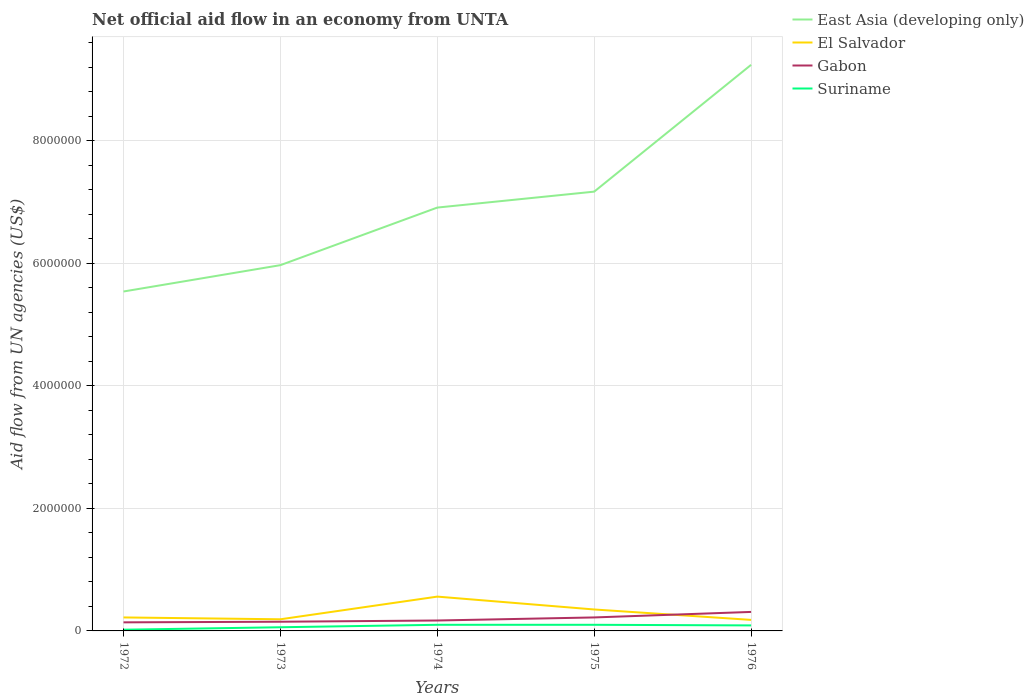In which year was the net official aid flow in El Salvador maximum?
Ensure brevity in your answer.  1976. What is the total net official aid flow in Gabon in the graph?
Offer a very short reply. -5.00e+04. How many lines are there?
Provide a short and direct response. 4. How many years are there in the graph?
Your answer should be very brief. 5. Are the values on the major ticks of Y-axis written in scientific E-notation?
Your answer should be compact. No. Does the graph contain any zero values?
Give a very brief answer. No. What is the title of the graph?
Keep it short and to the point. Net official aid flow in an economy from UNTA. Does "Greenland" appear as one of the legend labels in the graph?
Make the answer very short. No. What is the label or title of the Y-axis?
Make the answer very short. Aid flow from UN agencies (US$). What is the Aid flow from UN agencies (US$) of East Asia (developing only) in 1972?
Your answer should be very brief. 5.54e+06. What is the Aid flow from UN agencies (US$) in El Salvador in 1972?
Your response must be concise. 2.20e+05. What is the Aid flow from UN agencies (US$) of East Asia (developing only) in 1973?
Make the answer very short. 5.97e+06. What is the Aid flow from UN agencies (US$) in Gabon in 1973?
Your answer should be very brief. 1.50e+05. What is the Aid flow from UN agencies (US$) of Suriname in 1973?
Keep it short and to the point. 6.00e+04. What is the Aid flow from UN agencies (US$) in East Asia (developing only) in 1974?
Offer a very short reply. 6.91e+06. What is the Aid flow from UN agencies (US$) of El Salvador in 1974?
Give a very brief answer. 5.60e+05. What is the Aid flow from UN agencies (US$) of Gabon in 1974?
Keep it short and to the point. 1.70e+05. What is the Aid flow from UN agencies (US$) of East Asia (developing only) in 1975?
Ensure brevity in your answer.  7.17e+06. What is the Aid flow from UN agencies (US$) in Gabon in 1975?
Your response must be concise. 2.20e+05. What is the Aid flow from UN agencies (US$) in East Asia (developing only) in 1976?
Your answer should be very brief. 9.24e+06. What is the Aid flow from UN agencies (US$) of El Salvador in 1976?
Make the answer very short. 1.80e+05. What is the Aid flow from UN agencies (US$) in Gabon in 1976?
Offer a terse response. 3.10e+05. What is the Aid flow from UN agencies (US$) in Suriname in 1976?
Give a very brief answer. 9.00e+04. Across all years, what is the maximum Aid flow from UN agencies (US$) in East Asia (developing only)?
Offer a very short reply. 9.24e+06. Across all years, what is the maximum Aid flow from UN agencies (US$) in El Salvador?
Make the answer very short. 5.60e+05. Across all years, what is the minimum Aid flow from UN agencies (US$) of East Asia (developing only)?
Your answer should be compact. 5.54e+06. Across all years, what is the minimum Aid flow from UN agencies (US$) in Suriname?
Provide a succinct answer. 2.00e+04. What is the total Aid flow from UN agencies (US$) in East Asia (developing only) in the graph?
Make the answer very short. 3.48e+07. What is the total Aid flow from UN agencies (US$) in El Salvador in the graph?
Your answer should be compact. 1.50e+06. What is the total Aid flow from UN agencies (US$) in Gabon in the graph?
Ensure brevity in your answer.  9.90e+05. What is the difference between the Aid flow from UN agencies (US$) of East Asia (developing only) in 1972 and that in 1973?
Provide a short and direct response. -4.30e+05. What is the difference between the Aid flow from UN agencies (US$) in East Asia (developing only) in 1972 and that in 1974?
Provide a succinct answer. -1.37e+06. What is the difference between the Aid flow from UN agencies (US$) of Gabon in 1972 and that in 1974?
Your answer should be compact. -3.00e+04. What is the difference between the Aid flow from UN agencies (US$) in East Asia (developing only) in 1972 and that in 1975?
Ensure brevity in your answer.  -1.63e+06. What is the difference between the Aid flow from UN agencies (US$) in El Salvador in 1972 and that in 1975?
Provide a short and direct response. -1.30e+05. What is the difference between the Aid flow from UN agencies (US$) of Suriname in 1972 and that in 1975?
Your answer should be compact. -8.00e+04. What is the difference between the Aid flow from UN agencies (US$) of East Asia (developing only) in 1972 and that in 1976?
Offer a terse response. -3.70e+06. What is the difference between the Aid flow from UN agencies (US$) of Suriname in 1972 and that in 1976?
Keep it short and to the point. -7.00e+04. What is the difference between the Aid flow from UN agencies (US$) in East Asia (developing only) in 1973 and that in 1974?
Provide a succinct answer. -9.40e+05. What is the difference between the Aid flow from UN agencies (US$) in El Salvador in 1973 and that in 1974?
Provide a short and direct response. -3.70e+05. What is the difference between the Aid flow from UN agencies (US$) in Gabon in 1973 and that in 1974?
Make the answer very short. -2.00e+04. What is the difference between the Aid flow from UN agencies (US$) in Suriname in 1973 and that in 1974?
Give a very brief answer. -4.00e+04. What is the difference between the Aid flow from UN agencies (US$) in East Asia (developing only) in 1973 and that in 1975?
Provide a succinct answer. -1.20e+06. What is the difference between the Aid flow from UN agencies (US$) of Gabon in 1973 and that in 1975?
Offer a terse response. -7.00e+04. What is the difference between the Aid flow from UN agencies (US$) in East Asia (developing only) in 1973 and that in 1976?
Ensure brevity in your answer.  -3.27e+06. What is the difference between the Aid flow from UN agencies (US$) in El Salvador in 1973 and that in 1976?
Provide a succinct answer. 10000. What is the difference between the Aid flow from UN agencies (US$) of Suriname in 1973 and that in 1976?
Offer a terse response. -3.00e+04. What is the difference between the Aid flow from UN agencies (US$) of East Asia (developing only) in 1974 and that in 1975?
Provide a short and direct response. -2.60e+05. What is the difference between the Aid flow from UN agencies (US$) of Gabon in 1974 and that in 1975?
Keep it short and to the point. -5.00e+04. What is the difference between the Aid flow from UN agencies (US$) of Suriname in 1974 and that in 1975?
Keep it short and to the point. 0. What is the difference between the Aid flow from UN agencies (US$) in East Asia (developing only) in 1974 and that in 1976?
Offer a very short reply. -2.33e+06. What is the difference between the Aid flow from UN agencies (US$) in El Salvador in 1974 and that in 1976?
Give a very brief answer. 3.80e+05. What is the difference between the Aid flow from UN agencies (US$) in Gabon in 1974 and that in 1976?
Make the answer very short. -1.40e+05. What is the difference between the Aid flow from UN agencies (US$) of Suriname in 1974 and that in 1976?
Your response must be concise. 10000. What is the difference between the Aid flow from UN agencies (US$) in East Asia (developing only) in 1975 and that in 1976?
Your answer should be very brief. -2.07e+06. What is the difference between the Aid flow from UN agencies (US$) of Gabon in 1975 and that in 1976?
Provide a succinct answer. -9.00e+04. What is the difference between the Aid flow from UN agencies (US$) of East Asia (developing only) in 1972 and the Aid flow from UN agencies (US$) of El Salvador in 1973?
Your answer should be compact. 5.35e+06. What is the difference between the Aid flow from UN agencies (US$) in East Asia (developing only) in 1972 and the Aid flow from UN agencies (US$) in Gabon in 1973?
Your response must be concise. 5.39e+06. What is the difference between the Aid flow from UN agencies (US$) of East Asia (developing only) in 1972 and the Aid flow from UN agencies (US$) of Suriname in 1973?
Provide a succinct answer. 5.48e+06. What is the difference between the Aid flow from UN agencies (US$) in East Asia (developing only) in 1972 and the Aid flow from UN agencies (US$) in El Salvador in 1974?
Provide a short and direct response. 4.98e+06. What is the difference between the Aid flow from UN agencies (US$) of East Asia (developing only) in 1972 and the Aid flow from UN agencies (US$) of Gabon in 1974?
Keep it short and to the point. 5.37e+06. What is the difference between the Aid flow from UN agencies (US$) in East Asia (developing only) in 1972 and the Aid flow from UN agencies (US$) in Suriname in 1974?
Provide a short and direct response. 5.44e+06. What is the difference between the Aid flow from UN agencies (US$) of El Salvador in 1972 and the Aid flow from UN agencies (US$) of Gabon in 1974?
Your response must be concise. 5.00e+04. What is the difference between the Aid flow from UN agencies (US$) in El Salvador in 1972 and the Aid flow from UN agencies (US$) in Suriname in 1974?
Provide a short and direct response. 1.20e+05. What is the difference between the Aid flow from UN agencies (US$) of East Asia (developing only) in 1972 and the Aid flow from UN agencies (US$) of El Salvador in 1975?
Keep it short and to the point. 5.19e+06. What is the difference between the Aid flow from UN agencies (US$) of East Asia (developing only) in 1972 and the Aid flow from UN agencies (US$) of Gabon in 1975?
Give a very brief answer. 5.32e+06. What is the difference between the Aid flow from UN agencies (US$) in East Asia (developing only) in 1972 and the Aid flow from UN agencies (US$) in Suriname in 1975?
Keep it short and to the point. 5.44e+06. What is the difference between the Aid flow from UN agencies (US$) of Gabon in 1972 and the Aid flow from UN agencies (US$) of Suriname in 1975?
Your answer should be compact. 4.00e+04. What is the difference between the Aid flow from UN agencies (US$) of East Asia (developing only) in 1972 and the Aid flow from UN agencies (US$) of El Salvador in 1976?
Your answer should be very brief. 5.36e+06. What is the difference between the Aid flow from UN agencies (US$) in East Asia (developing only) in 1972 and the Aid flow from UN agencies (US$) in Gabon in 1976?
Offer a very short reply. 5.23e+06. What is the difference between the Aid flow from UN agencies (US$) in East Asia (developing only) in 1972 and the Aid flow from UN agencies (US$) in Suriname in 1976?
Your answer should be very brief. 5.45e+06. What is the difference between the Aid flow from UN agencies (US$) of El Salvador in 1972 and the Aid flow from UN agencies (US$) of Gabon in 1976?
Your answer should be very brief. -9.00e+04. What is the difference between the Aid flow from UN agencies (US$) of East Asia (developing only) in 1973 and the Aid flow from UN agencies (US$) of El Salvador in 1974?
Your response must be concise. 5.41e+06. What is the difference between the Aid flow from UN agencies (US$) of East Asia (developing only) in 1973 and the Aid flow from UN agencies (US$) of Gabon in 1974?
Offer a very short reply. 5.80e+06. What is the difference between the Aid flow from UN agencies (US$) in East Asia (developing only) in 1973 and the Aid flow from UN agencies (US$) in Suriname in 1974?
Ensure brevity in your answer.  5.87e+06. What is the difference between the Aid flow from UN agencies (US$) in El Salvador in 1973 and the Aid flow from UN agencies (US$) in Gabon in 1974?
Keep it short and to the point. 2.00e+04. What is the difference between the Aid flow from UN agencies (US$) in Gabon in 1973 and the Aid flow from UN agencies (US$) in Suriname in 1974?
Give a very brief answer. 5.00e+04. What is the difference between the Aid flow from UN agencies (US$) of East Asia (developing only) in 1973 and the Aid flow from UN agencies (US$) of El Salvador in 1975?
Offer a terse response. 5.62e+06. What is the difference between the Aid flow from UN agencies (US$) of East Asia (developing only) in 1973 and the Aid flow from UN agencies (US$) of Gabon in 1975?
Make the answer very short. 5.75e+06. What is the difference between the Aid flow from UN agencies (US$) of East Asia (developing only) in 1973 and the Aid flow from UN agencies (US$) of Suriname in 1975?
Give a very brief answer. 5.87e+06. What is the difference between the Aid flow from UN agencies (US$) of El Salvador in 1973 and the Aid flow from UN agencies (US$) of Gabon in 1975?
Offer a terse response. -3.00e+04. What is the difference between the Aid flow from UN agencies (US$) of El Salvador in 1973 and the Aid flow from UN agencies (US$) of Suriname in 1975?
Give a very brief answer. 9.00e+04. What is the difference between the Aid flow from UN agencies (US$) of East Asia (developing only) in 1973 and the Aid flow from UN agencies (US$) of El Salvador in 1976?
Your answer should be compact. 5.79e+06. What is the difference between the Aid flow from UN agencies (US$) of East Asia (developing only) in 1973 and the Aid flow from UN agencies (US$) of Gabon in 1976?
Ensure brevity in your answer.  5.66e+06. What is the difference between the Aid flow from UN agencies (US$) of East Asia (developing only) in 1973 and the Aid flow from UN agencies (US$) of Suriname in 1976?
Offer a very short reply. 5.88e+06. What is the difference between the Aid flow from UN agencies (US$) of El Salvador in 1973 and the Aid flow from UN agencies (US$) of Gabon in 1976?
Keep it short and to the point. -1.20e+05. What is the difference between the Aid flow from UN agencies (US$) in East Asia (developing only) in 1974 and the Aid flow from UN agencies (US$) in El Salvador in 1975?
Provide a succinct answer. 6.56e+06. What is the difference between the Aid flow from UN agencies (US$) of East Asia (developing only) in 1974 and the Aid flow from UN agencies (US$) of Gabon in 1975?
Keep it short and to the point. 6.69e+06. What is the difference between the Aid flow from UN agencies (US$) of East Asia (developing only) in 1974 and the Aid flow from UN agencies (US$) of Suriname in 1975?
Your response must be concise. 6.81e+06. What is the difference between the Aid flow from UN agencies (US$) in El Salvador in 1974 and the Aid flow from UN agencies (US$) in Suriname in 1975?
Provide a succinct answer. 4.60e+05. What is the difference between the Aid flow from UN agencies (US$) of Gabon in 1974 and the Aid flow from UN agencies (US$) of Suriname in 1975?
Keep it short and to the point. 7.00e+04. What is the difference between the Aid flow from UN agencies (US$) of East Asia (developing only) in 1974 and the Aid flow from UN agencies (US$) of El Salvador in 1976?
Offer a terse response. 6.73e+06. What is the difference between the Aid flow from UN agencies (US$) of East Asia (developing only) in 1974 and the Aid flow from UN agencies (US$) of Gabon in 1976?
Give a very brief answer. 6.60e+06. What is the difference between the Aid flow from UN agencies (US$) of East Asia (developing only) in 1974 and the Aid flow from UN agencies (US$) of Suriname in 1976?
Provide a succinct answer. 6.82e+06. What is the difference between the Aid flow from UN agencies (US$) in El Salvador in 1974 and the Aid flow from UN agencies (US$) in Gabon in 1976?
Your answer should be very brief. 2.50e+05. What is the difference between the Aid flow from UN agencies (US$) in East Asia (developing only) in 1975 and the Aid flow from UN agencies (US$) in El Salvador in 1976?
Offer a very short reply. 6.99e+06. What is the difference between the Aid flow from UN agencies (US$) in East Asia (developing only) in 1975 and the Aid flow from UN agencies (US$) in Gabon in 1976?
Your answer should be compact. 6.86e+06. What is the difference between the Aid flow from UN agencies (US$) of East Asia (developing only) in 1975 and the Aid flow from UN agencies (US$) of Suriname in 1976?
Keep it short and to the point. 7.08e+06. What is the difference between the Aid flow from UN agencies (US$) of El Salvador in 1975 and the Aid flow from UN agencies (US$) of Gabon in 1976?
Offer a terse response. 4.00e+04. What is the difference between the Aid flow from UN agencies (US$) in El Salvador in 1975 and the Aid flow from UN agencies (US$) in Suriname in 1976?
Make the answer very short. 2.60e+05. What is the difference between the Aid flow from UN agencies (US$) of Gabon in 1975 and the Aid flow from UN agencies (US$) of Suriname in 1976?
Provide a short and direct response. 1.30e+05. What is the average Aid flow from UN agencies (US$) of East Asia (developing only) per year?
Provide a succinct answer. 6.97e+06. What is the average Aid flow from UN agencies (US$) in Gabon per year?
Keep it short and to the point. 1.98e+05. What is the average Aid flow from UN agencies (US$) of Suriname per year?
Your answer should be compact. 7.40e+04. In the year 1972, what is the difference between the Aid flow from UN agencies (US$) of East Asia (developing only) and Aid flow from UN agencies (US$) of El Salvador?
Your response must be concise. 5.32e+06. In the year 1972, what is the difference between the Aid flow from UN agencies (US$) in East Asia (developing only) and Aid flow from UN agencies (US$) in Gabon?
Provide a succinct answer. 5.40e+06. In the year 1972, what is the difference between the Aid flow from UN agencies (US$) of East Asia (developing only) and Aid flow from UN agencies (US$) of Suriname?
Keep it short and to the point. 5.52e+06. In the year 1972, what is the difference between the Aid flow from UN agencies (US$) in Gabon and Aid flow from UN agencies (US$) in Suriname?
Your response must be concise. 1.20e+05. In the year 1973, what is the difference between the Aid flow from UN agencies (US$) in East Asia (developing only) and Aid flow from UN agencies (US$) in El Salvador?
Offer a terse response. 5.78e+06. In the year 1973, what is the difference between the Aid flow from UN agencies (US$) in East Asia (developing only) and Aid flow from UN agencies (US$) in Gabon?
Give a very brief answer. 5.82e+06. In the year 1973, what is the difference between the Aid flow from UN agencies (US$) of East Asia (developing only) and Aid flow from UN agencies (US$) of Suriname?
Give a very brief answer. 5.91e+06. In the year 1973, what is the difference between the Aid flow from UN agencies (US$) of Gabon and Aid flow from UN agencies (US$) of Suriname?
Keep it short and to the point. 9.00e+04. In the year 1974, what is the difference between the Aid flow from UN agencies (US$) in East Asia (developing only) and Aid flow from UN agencies (US$) in El Salvador?
Your answer should be compact. 6.35e+06. In the year 1974, what is the difference between the Aid flow from UN agencies (US$) of East Asia (developing only) and Aid flow from UN agencies (US$) of Gabon?
Provide a short and direct response. 6.74e+06. In the year 1974, what is the difference between the Aid flow from UN agencies (US$) of East Asia (developing only) and Aid flow from UN agencies (US$) of Suriname?
Ensure brevity in your answer.  6.81e+06. In the year 1974, what is the difference between the Aid flow from UN agencies (US$) in Gabon and Aid flow from UN agencies (US$) in Suriname?
Keep it short and to the point. 7.00e+04. In the year 1975, what is the difference between the Aid flow from UN agencies (US$) of East Asia (developing only) and Aid flow from UN agencies (US$) of El Salvador?
Make the answer very short. 6.82e+06. In the year 1975, what is the difference between the Aid flow from UN agencies (US$) in East Asia (developing only) and Aid flow from UN agencies (US$) in Gabon?
Your answer should be compact. 6.95e+06. In the year 1975, what is the difference between the Aid flow from UN agencies (US$) of East Asia (developing only) and Aid flow from UN agencies (US$) of Suriname?
Offer a very short reply. 7.07e+06. In the year 1975, what is the difference between the Aid flow from UN agencies (US$) of El Salvador and Aid flow from UN agencies (US$) of Suriname?
Your answer should be very brief. 2.50e+05. In the year 1975, what is the difference between the Aid flow from UN agencies (US$) in Gabon and Aid flow from UN agencies (US$) in Suriname?
Offer a very short reply. 1.20e+05. In the year 1976, what is the difference between the Aid flow from UN agencies (US$) of East Asia (developing only) and Aid flow from UN agencies (US$) of El Salvador?
Provide a succinct answer. 9.06e+06. In the year 1976, what is the difference between the Aid flow from UN agencies (US$) of East Asia (developing only) and Aid flow from UN agencies (US$) of Gabon?
Offer a very short reply. 8.93e+06. In the year 1976, what is the difference between the Aid flow from UN agencies (US$) in East Asia (developing only) and Aid flow from UN agencies (US$) in Suriname?
Make the answer very short. 9.15e+06. In the year 1976, what is the difference between the Aid flow from UN agencies (US$) of El Salvador and Aid flow from UN agencies (US$) of Gabon?
Give a very brief answer. -1.30e+05. In the year 1976, what is the difference between the Aid flow from UN agencies (US$) of Gabon and Aid flow from UN agencies (US$) of Suriname?
Provide a short and direct response. 2.20e+05. What is the ratio of the Aid flow from UN agencies (US$) in East Asia (developing only) in 1972 to that in 1973?
Your answer should be compact. 0.93. What is the ratio of the Aid flow from UN agencies (US$) of El Salvador in 1972 to that in 1973?
Your answer should be very brief. 1.16. What is the ratio of the Aid flow from UN agencies (US$) of Suriname in 1972 to that in 1973?
Your answer should be compact. 0.33. What is the ratio of the Aid flow from UN agencies (US$) in East Asia (developing only) in 1972 to that in 1974?
Give a very brief answer. 0.8. What is the ratio of the Aid flow from UN agencies (US$) of El Salvador in 1972 to that in 1974?
Keep it short and to the point. 0.39. What is the ratio of the Aid flow from UN agencies (US$) in Gabon in 1972 to that in 1974?
Your response must be concise. 0.82. What is the ratio of the Aid flow from UN agencies (US$) in East Asia (developing only) in 1972 to that in 1975?
Offer a terse response. 0.77. What is the ratio of the Aid flow from UN agencies (US$) of El Salvador in 1972 to that in 1975?
Keep it short and to the point. 0.63. What is the ratio of the Aid flow from UN agencies (US$) of Gabon in 1972 to that in 1975?
Make the answer very short. 0.64. What is the ratio of the Aid flow from UN agencies (US$) in East Asia (developing only) in 1972 to that in 1976?
Make the answer very short. 0.6. What is the ratio of the Aid flow from UN agencies (US$) of El Salvador in 1972 to that in 1976?
Your answer should be compact. 1.22. What is the ratio of the Aid flow from UN agencies (US$) in Gabon in 1972 to that in 1976?
Your answer should be very brief. 0.45. What is the ratio of the Aid flow from UN agencies (US$) of Suriname in 1972 to that in 1976?
Offer a very short reply. 0.22. What is the ratio of the Aid flow from UN agencies (US$) in East Asia (developing only) in 1973 to that in 1974?
Ensure brevity in your answer.  0.86. What is the ratio of the Aid flow from UN agencies (US$) in El Salvador in 1973 to that in 1974?
Your answer should be very brief. 0.34. What is the ratio of the Aid flow from UN agencies (US$) in Gabon in 1973 to that in 1974?
Provide a short and direct response. 0.88. What is the ratio of the Aid flow from UN agencies (US$) of Suriname in 1973 to that in 1974?
Your response must be concise. 0.6. What is the ratio of the Aid flow from UN agencies (US$) in East Asia (developing only) in 1973 to that in 1975?
Offer a terse response. 0.83. What is the ratio of the Aid flow from UN agencies (US$) of El Salvador in 1973 to that in 1975?
Offer a very short reply. 0.54. What is the ratio of the Aid flow from UN agencies (US$) of Gabon in 1973 to that in 1975?
Give a very brief answer. 0.68. What is the ratio of the Aid flow from UN agencies (US$) in Suriname in 1973 to that in 1975?
Provide a short and direct response. 0.6. What is the ratio of the Aid flow from UN agencies (US$) of East Asia (developing only) in 1973 to that in 1976?
Your answer should be very brief. 0.65. What is the ratio of the Aid flow from UN agencies (US$) in El Salvador in 1973 to that in 1976?
Your response must be concise. 1.06. What is the ratio of the Aid flow from UN agencies (US$) of Gabon in 1973 to that in 1976?
Your response must be concise. 0.48. What is the ratio of the Aid flow from UN agencies (US$) of Suriname in 1973 to that in 1976?
Offer a terse response. 0.67. What is the ratio of the Aid flow from UN agencies (US$) of East Asia (developing only) in 1974 to that in 1975?
Offer a terse response. 0.96. What is the ratio of the Aid flow from UN agencies (US$) of Gabon in 1974 to that in 1975?
Your answer should be very brief. 0.77. What is the ratio of the Aid flow from UN agencies (US$) in East Asia (developing only) in 1974 to that in 1976?
Your answer should be very brief. 0.75. What is the ratio of the Aid flow from UN agencies (US$) of El Salvador in 1974 to that in 1976?
Ensure brevity in your answer.  3.11. What is the ratio of the Aid flow from UN agencies (US$) in Gabon in 1974 to that in 1976?
Make the answer very short. 0.55. What is the ratio of the Aid flow from UN agencies (US$) in East Asia (developing only) in 1975 to that in 1976?
Keep it short and to the point. 0.78. What is the ratio of the Aid flow from UN agencies (US$) of El Salvador in 1975 to that in 1976?
Ensure brevity in your answer.  1.94. What is the ratio of the Aid flow from UN agencies (US$) in Gabon in 1975 to that in 1976?
Provide a succinct answer. 0.71. What is the ratio of the Aid flow from UN agencies (US$) of Suriname in 1975 to that in 1976?
Offer a terse response. 1.11. What is the difference between the highest and the second highest Aid flow from UN agencies (US$) in East Asia (developing only)?
Make the answer very short. 2.07e+06. What is the difference between the highest and the second highest Aid flow from UN agencies (US$) in El Salvador?
Offer a very short reply. 2.10e+05. What is the difference between the highest and the lowest Aid flow from UN agencies (US$) in East Asia (developing only)?
Provide a short and direct response. 3.70e+06. What is the difference between the highest and the lowest Aid flow from UN agencies (US$) in El Salvador?
Make the answer very short. 3.80e+05. What is the difference between the highest and the lowest Aid flow from UN agencies (US$) in Suriname?
Offer a terse response. 8.00e+04. 